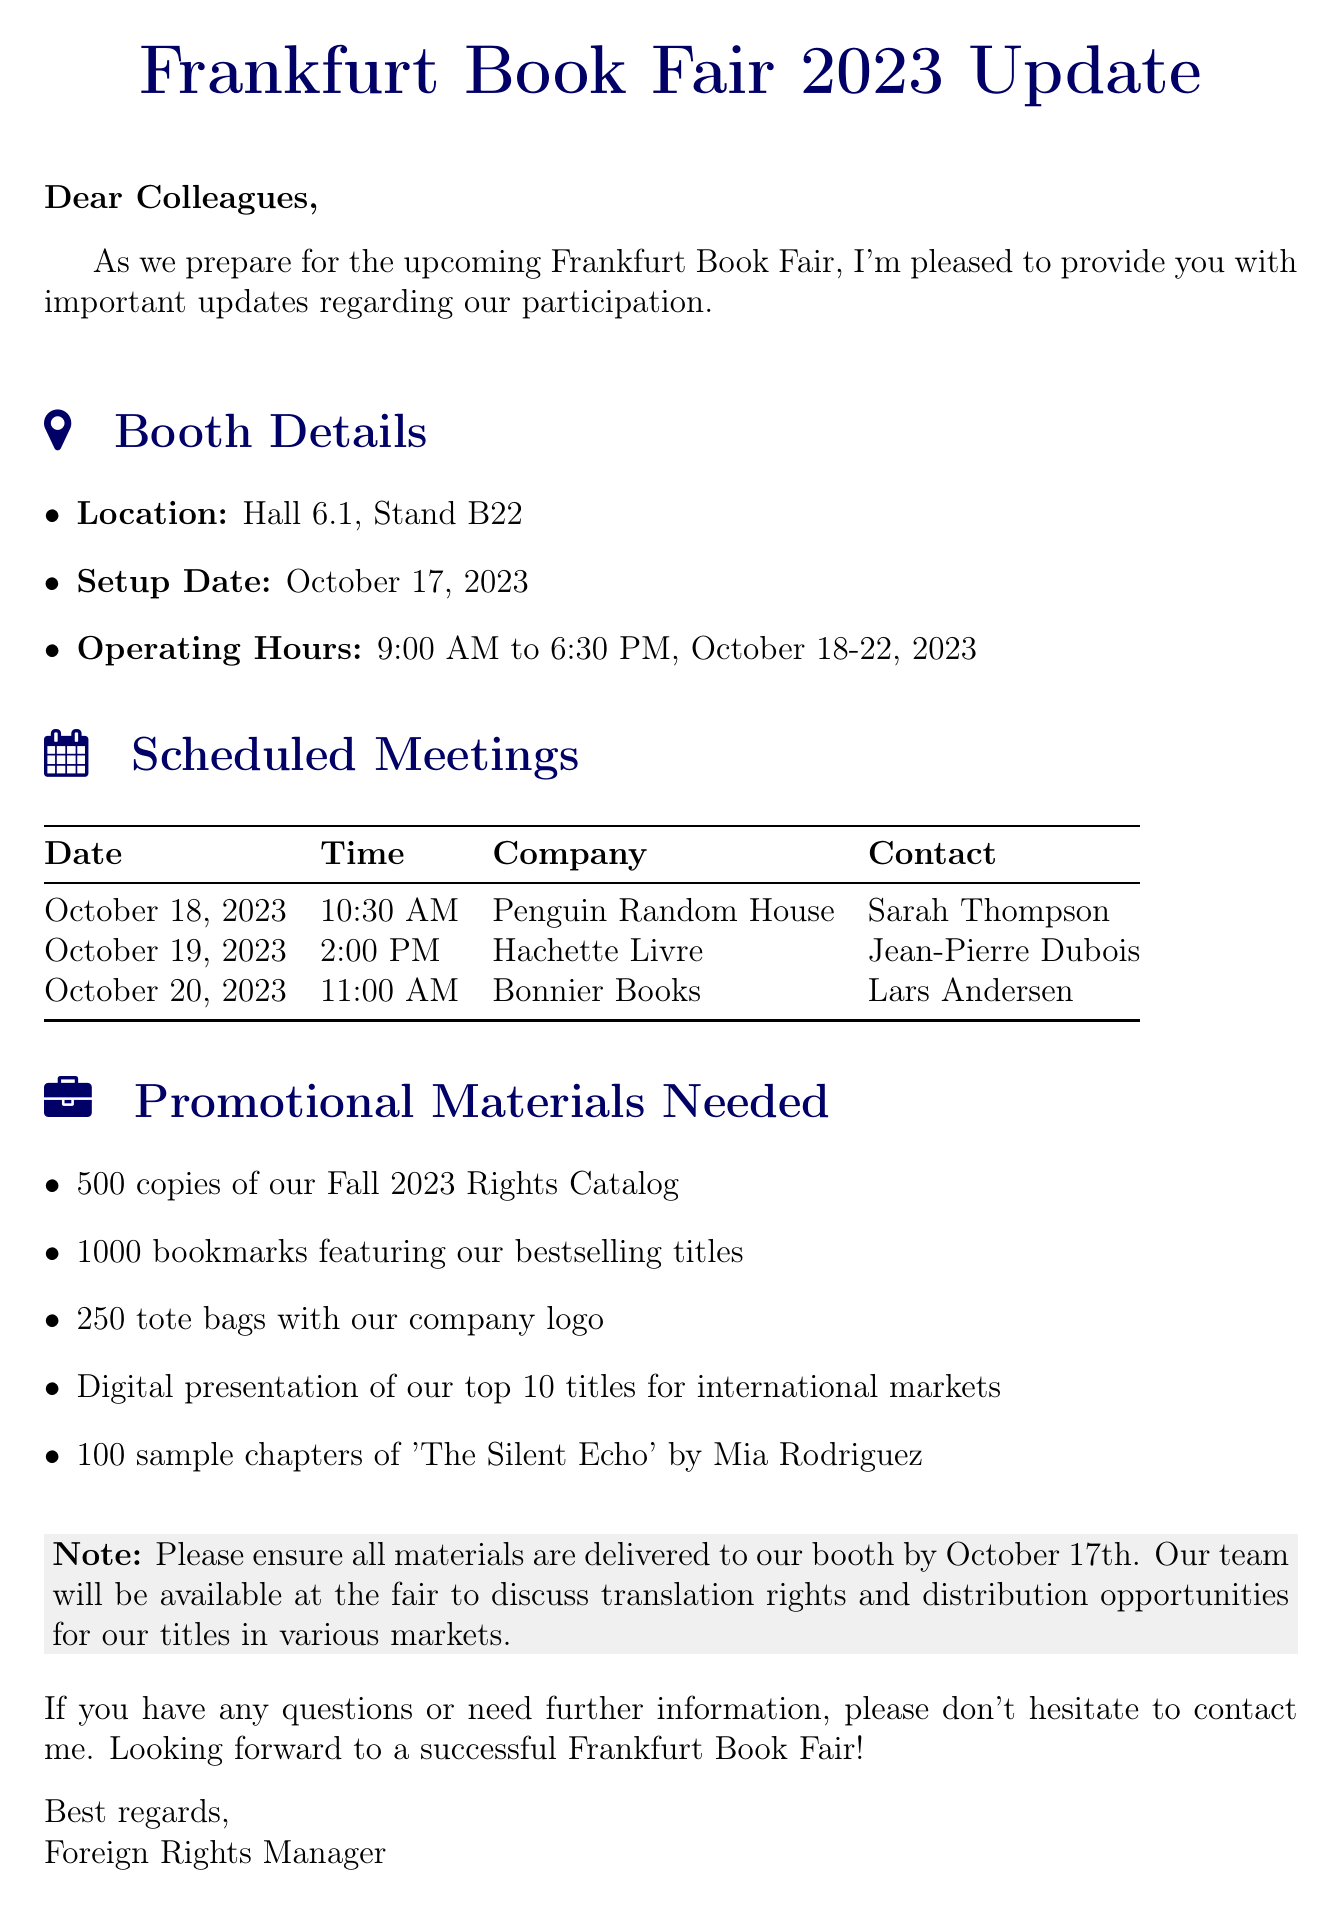what is the booth location? The booth location is specified in the document under booth details, providing a specific hall and stand number.
Answer: Hall 6.1, Stand B22 what is the setup date for the booth? The setup date is indicated in the booth details section of the document.
Answer: October 17, 2023 how many copies of the Fall 2023 Rights Catalog are needed? The document lists the number of copies required for the Fall 2023 Rights Catalog in the promotional materials section.
Answer: 500 who is the contact for the meeting with Penguin Random House? The document includes contact names for scheduled meetings, specifying who to meet for each company.
Answer: Sarah Thompson when do the operating hours start at the book fair? The operating hours section in the document provides the start time for the book fair days.
Answer: 9:00 AM what is the date of the meeting with Hachette Livre? The date is specified for each scheduled meeting in the document under scheduled meetings.
Answer: October 19, 2023 which title has sample chapters needed for promotion? The promotional materials section of the document lists the specific title for which sample chapters are required.
Answer: The Silent Echo how many tote bags are needed for the fair? The number of tote bags needed is stated clearly in the promotional materials needed section of the document.
Answer: 250 what additional information is provided in the document? The document includes a note that contains further instructions or information relevant to the booth setup and fair participation.
Answer: Please ensure all materials are delivered to our booth by October 17th 